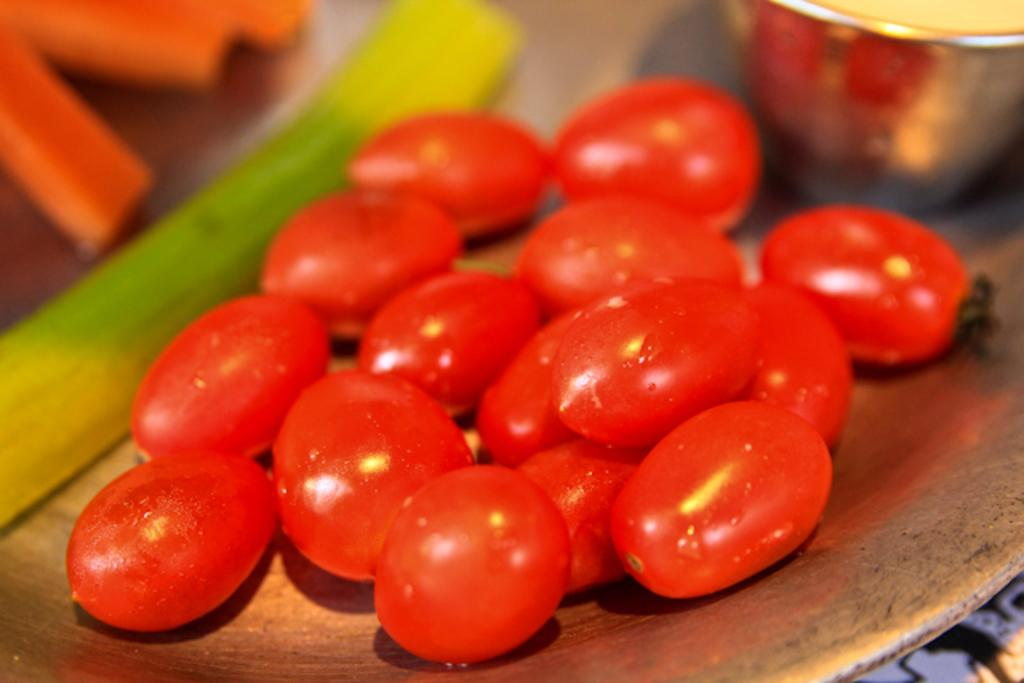What object is located in the front of the image? There is a plate in the front of the image. What else can be seen in the image besides the plate? There is a glass in the image. What is on the plate? There are fruits on the plate. Can you describe the background of the image? The background of the image is blurry. What type of apples are being served in the afternoon in the image? There are no apples present in the image, and the time of day is not mentioned. 